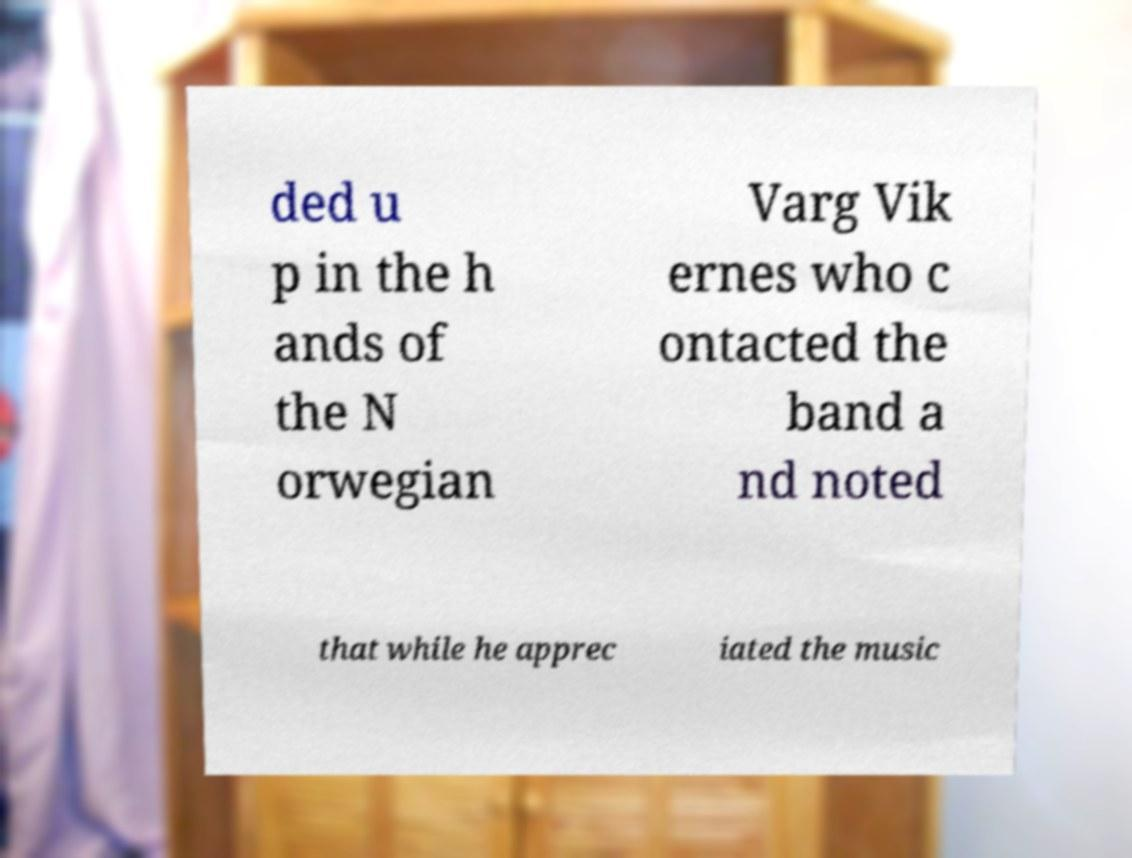I need the written content from this picture converted into text. Can you do that? ded u p in the h ands of the N orwegian Varg Vik ernes who c ontacted the band a nd noted that while he apprec iated the music 